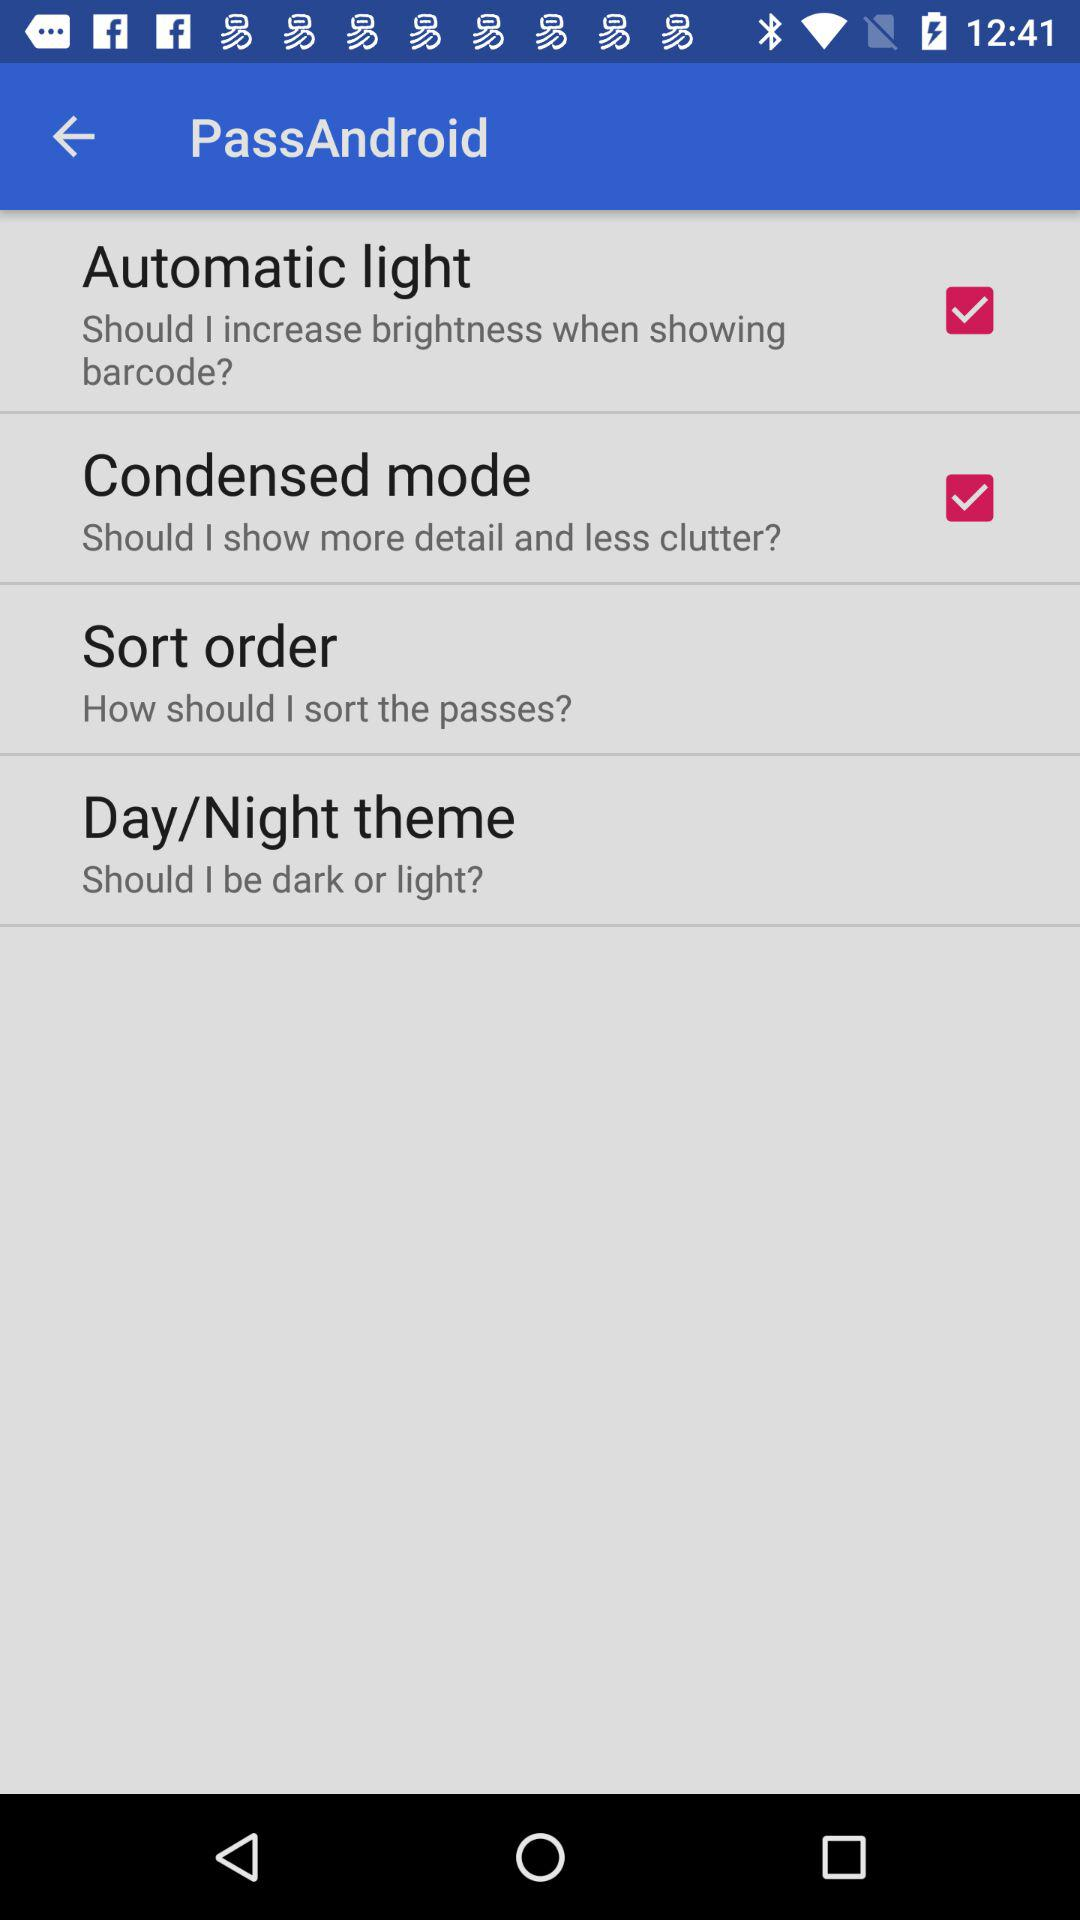What is the status of the "Automatic light"? The status of the "Automatic light" is "on". 